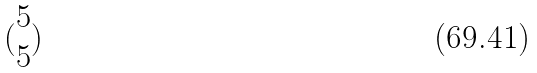<formula> <loc_0><loc_0><loc_500><loc_500>( \begin{matrix} 5 \\ 5 \end{matrix} )</formula> 